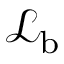<formula> <loc_0><loc_0><loc_500><loc_500>{ \mathcal { L } } _ { \mathrm b }</formula> 